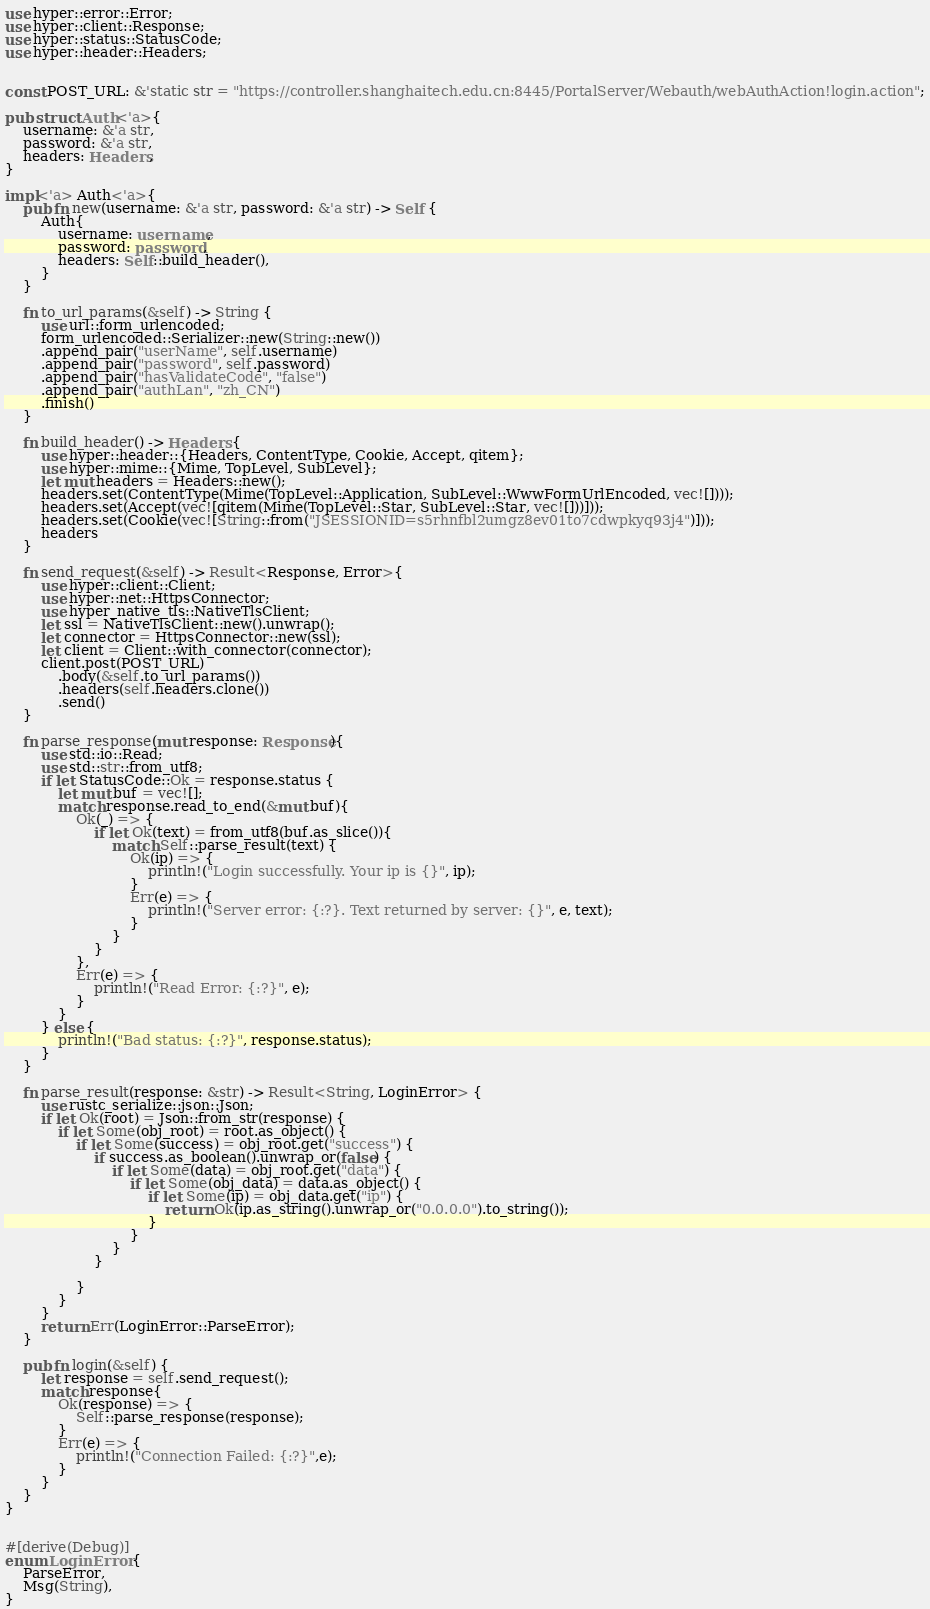Convert code to text. <code><loc_0><loc_0><loc_500><loc_500><_Rust_>use hyper::error::Error;
use hyper::client::Response;
use hyper::status::StatusCode;
use hyper::header::Headers;


const POST_URL: &'static str = "https://controller.shanghaitech.edu.cn:8445/PortalServer/Webauth/webAuthAction!login.action";

pub struct Auth<'a>{
    username: &'a str,
    password: &'a str,
    headers: Headers,
}

impl<'a> Auth<'a>{
    pub fn new(username: &'a str, password: &'a str) -> Self {
        Auth{
            username: username,
            password: password,
            headers: Self::build_header(),
        }
    }

    fn to_url_params(&self) -> String {
        use url::form_urlencoded;
        form_urlencoded::Serializer::new(String::new())
        .append_pair("userName", self.username)
        .append_pair("password", self.password)
        .append_pair("hasValidateCode", "false")
        .append_pair("authLan", "zh_CN")
        .finish()
    }

    fn build_header() -> Headers {
        use hyper::header::{Headers, ContentType, Cookie, Accept, qitem};
        use hyper::mime::{Mime, TopLevel, SubLevel};
        let mut headers = Headers::new();
        headers.set(ContentType(Mime(TopLevel::Application, SubLevel::WwwFormUrlEncoded, vec![])));
        headers.set(Accept(vec![qitem(Mime(TopLevel::Star, SubLevel::Star, vec![]))]));
        headers.set(Cookie(vec![String::from("JSESSIONID=s5rhnfbl2umgz8ev01to7cdwpkyq93j4")]));
        headers
    }

    fn send_request(&self) -> Result<Response, Error>{
        use hyper::client::Client;
        use hyper::net::HttpsConnector;
        use hyper_native_tls::NativeTlsClient;
        let ssl = NativeTlsClient::new().unwrap();
        let connector = HttpsConnector::new(ssl);
        let client = Client::with_connector(connector);
        client.post(POST_URL)
            .body(&self.to_url_params())
            .headers(self.headers.clone())
            .send()
    }

    fn parse_response(mut response: Response){
        use std::io::Read;
        use std::str::from_utf8;
        if let StatusCode::Ok = response.status {
            let mut buf = vec![];
            match response.read_to_end(&mut buf){
                Ok(_) => {
                    if let Ok(text) = from_utf8(buf.as_slice()){
                        match Self::parse_result(text) {
                            Ok(ip) => {
                                println!("Login successfully. Your ip is {}", ip);
                            }
                            Err(e) => {
                                println!("Server error: {:?}. Text returned by server: {}", e, text);
                            }
                        }
                    }
                },
                Err(e) => {
                    println!("Read Error: {:?}", e);
                }
            }
        } else {
            println!("Bad status: {:?}", response.status);
        }
    }

    fn parse_result(response: &str) -> Result<String, LoginError> {
        use rustc_serialize::json::Json;
        if let Ok(root) = Json::from_str(response) {
            if let Some(obj_root) = root.as_object() {
                if let Some(success) = obj_root.get("success") {
                    if success.as_boolean().unwrap_or(false) {
                        if let Some(data) = obj_root.get("data") {
                            if let Some(obj_data) = data.as_object() {
                                if let Some(ip) = obj_data.get("ip") {
                                    return Ok(ip.as_string().unwrap_or("0.0.0.0").to_string());
                                }
                            }
                        }
                    }

                }
            }
        }
        return Err(LoginError::ParseError);
    }

    pub fn login(&self) {
        let response = self.send_request();
        match response{
            Ok(response) => {
                Self::parse_response(response);
            }
            Err(e) => {
                println!("Connection Failed: {:?}",e);
            }
        }
    }
}


#[derive(Debug)]
enum LoginError {
    ParseError,
    Msg(String),
}
</code> 